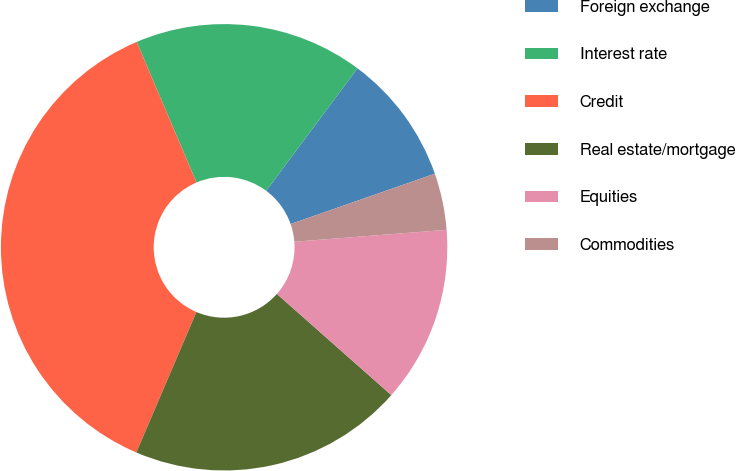<chart> <loc_0><loc_0><loc_500><loc_500><pie_chart><fcel>Foreign exchange<fcel>Interest rate<fcel>Credit<fcel>Real estate/mortgage<fcel>Equities<fcel>Commodities<nl><fcel>9.46%<fcel>16.6%<fcel>37.16%<fcel>19.91%<fcel>12.77%<fcel>4.1%<nl></chart> 